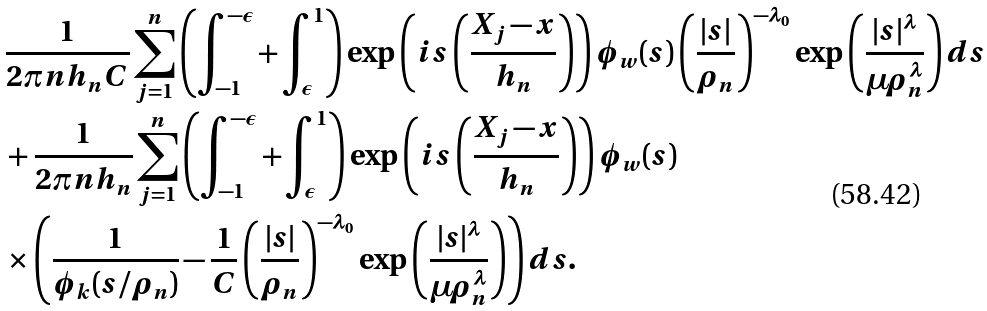Convert formula to latex. <formula><loc_0><loc_0><loc_500><loc_500>& \frac { 1 } { 2 \pi n h _ { n } C } \sum _ { j = 1 } ^ { n } \left ( \int _ { - 1 } ^ { - \epsilon } + \int _ { \epsilon } ^ { 1 } \right ) \exp \left ( i s \left ( \frac { X _ { j } - x } { h _ { n } } \right ) \right ) \phi _ { w } ( s ) \left ( \frac { | s | } { \rho _ { n } } \right ) ^ { - \lambda _ { 0 } } \exp \left ( \frac { | s | ^ { \lambda } } { \mu \rho _ { n } ^ { \lambda } } \right ) d s \\ & + \frac { 1 } { 2 \pi n h _ { n } } \sum _ { j = 1 } ^ { n } \left ( \int _ { - 1 } ^ { - \epsilon } + \int _ { \epsilon } ^ { 1 } \right ) \exp \left ( i s \left ( \frac { X _ { j } - x } { h _ { n } } \right ) \right ) \phi _ { w } ( s ) \\ & \times \left ( \frac { 1 } { \phi _ { k } ( s / \rho _ { n } ) } - \frac { 1 } { C } \left ( \frac { | s | } { \rho _ { n } } \right ) ^ { - \lambda _ { 0 } } \exp \left ( \frac { | s | ^ { \lambda } } { \mu \rho _ { n } ^ { \lambda } } \right ) \right ) d s .</formula> 